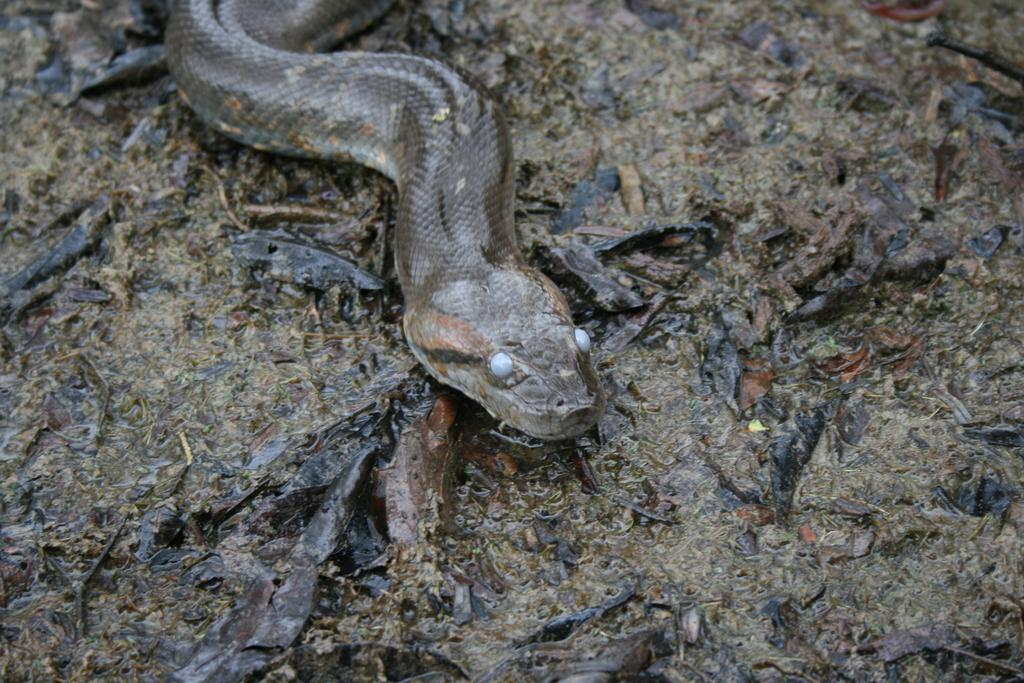What animal is present in the image? There is a snake in the image. What is the snake doing in the image? The snake is crawling on the ground. What type of watch is the snake wearing in the image? There is no watch present in the image, as snakes do not wear watches. 